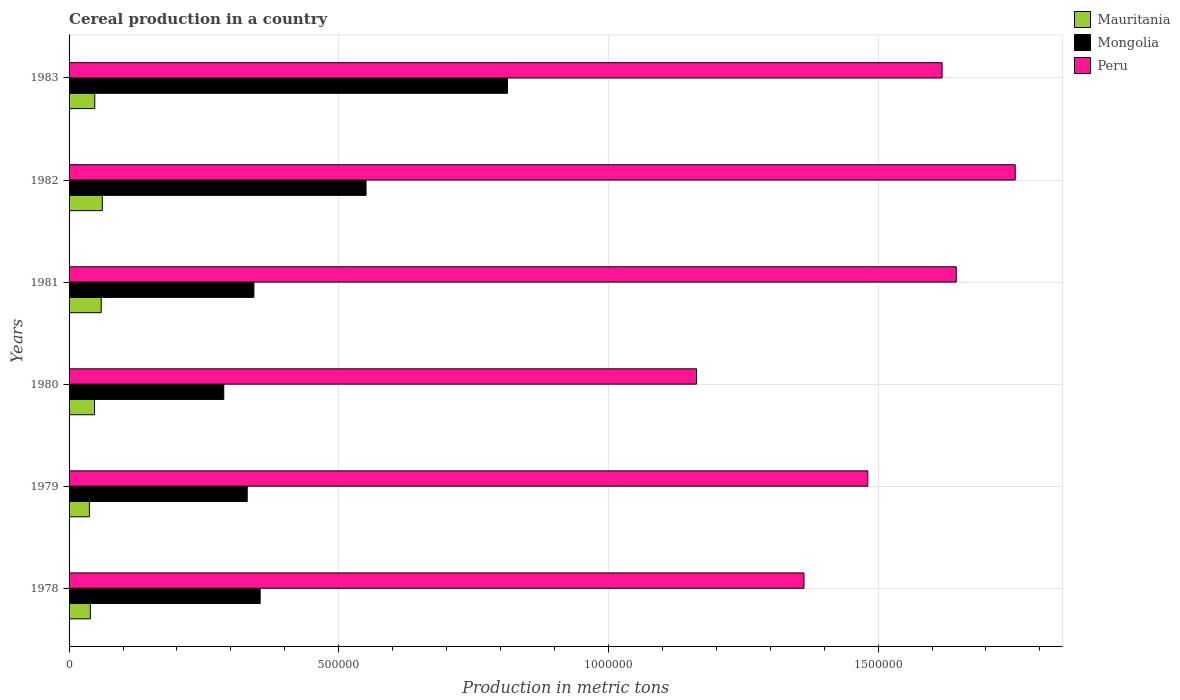Are the number of bars per tick equal to the number of legend labels?
Your response must be concise. Yes. Are the number of bars on each tick of the Y-axis equal?
Offer a very short reply. Yes. How many bars are there on the 3rd tick from the top?
Your answer should be very brief. 3. What is the label of the 6th group of bars from the top?
Offer a very short reply. 1978. In how many cases, is the number of bars for a given year not equal to the number of legend labels?
Offer a terse response. 0. What is the total cereal production in Mauritania in 1982?
Make the answer very short. 6.16e+04. Across all years, what is the maximum total cereal production in Mauritania?
Offer a terse response. 6.16e+04. Across all years, what is the minimum total cereal production in Mongolia?
Keep it short and to the point. 2.87e+05. In which year was the total cereal production in Peru maximum?
Give a very brief answer. 1982. In which year was the total cereal production in Peru minimum?
Make the answer very short. 1980. What is the total total cereal production in Mauritania in the graph?
Your response must be concise. 2.93e+05. What is the difference between the total cereal production in Mongolia in 1978 and that in 1980?
Give a very brief answer. 6.75e+04. What is the difference between the total cereal production in Mauritania in 1978 and the total cereal production in Peru in 1982?
Offer a very short reply. -1.71e+06. What is the average total cereal production in Mauritania per year?
Your answer should be very brief. 4.89e+04. In the year 1983, what is the difference between the total cereal production in Peru and total cereal production in Mauritania?
Give a very brief answer. 1.57e+06. What is the ratio of the total cereal production in Peru in 1980 to that in 1983?
Offer a terse response. 0.72. What is the difference between the highest and the second highest total cereal production in Mongolia?
Provide a succinct answer. 2.62e+05. What is the difference between the highest and the lowest total cereal production in Mongolia?
Offer a terse response. 5.26e+05. What does the 2nd bar from the top in 1979 represents?
Provide a short and direct response. Mongolia. What does the 1st bar from the bottom in 1983 represents?
Your answer should be very brief. Mauritania. Is it the case that in every year, the sum of the total cereal production in Peru and total cereal production in Mauritania is greater than the total cereal production in Mongolia?
Offer a terse response. Yes. Are all the bars in the graph horizontal?
Your answer should be very brief. Yes. How many years are there in the graph?
Ensure brevity in your answer.  6. What is the difference between two consecutive major ticks on the X-axis?
Your answer should be compact. 5.00e+05. How many legend labels are there?
Your answer should be compact. 3. What is the title of the graph?
Offer a very short reply. Cereal production in a country. What is the label or title of the X-axis?
Your answer should be very brief. Production in metric tons. What is the Production in metric tons in Mauritania in 1978?
Make the answer very short. 3.94e+04. What is the Production in metric tons of Mongolia in 1978?
Your answer should be compact. 3.54e+05. What is the Production in metric tons of Peru in 1978?
Make the answer very short. 1.36e+06. What is the Production in metric tons of Mauritania in 1979?
Provide a succinct answer. 3.77e+04. What is the Production in metric tons of Mongolia in 1979?
Your answer should be very brief. 3.30e+05. What is the Production in metric tons in Peru in 1979?
Offer a terse response. 1.48e+06. What is the Production in metric tons of Mauritania in 1980?
Your answer should be very brief. 4.72e+04. What is the Production in metric tons in Mongolia in 1980?
Your answer should be very brief. 2.87e+05. What is the Production in metric tons in Peru in 1980?
Your answer should be compact. 1.16e+06. What is the Production in metric tons of Mauritania in 1981?
Your answer should be very brief. 5.96e+04. What is the Production in metric tons of Mongolia in 1981?
Provide a short and direct response. 3.43e+05. What is the Production in metric tons in Peru in 1981?
Offer a terse response. 1.64e+06. What is the Production in metric tons of Mauritania in 1982?
Your answer should be compact. 6.16e+04. What is the Production in metric tons of Mongolia in 1982?
Provide a succinct answer. 5.51e+05. What is the Production in metric tons of Peru in 1982?
Your answer should be very brief. 1.75e+06. What is the Production in metric tons in Mauritania in 1983?
Provide a succinct answer. 4.76e+04. What is the Production in metric tons of Mongolia in 1983?
Your answer should be very brief. 8.13e+05. What is the Production in metric tons of Peru in 1983?
Your answer should be very brief. 1.62e+06. Across all years, what is the maximum Production in metric tons in Mauritania?
Offer a terse response. 6.16e+04. Across all years, what is the maximum Production in metric tons in Mongolia?
Make the answer very short. 8.13e+05. Across all years, what is the maximum Production in metric tons in Peru?
Make the answer very short. 1.75e+06. Across all years, what is the minimum Production in metric tons in Mauritania?
Offer a very short reply. 3.77e+04. Across all years, what is the minimum Production in metric tons of Mongolia?
Ensure brevity in your answer.  2.87e+05. Across all years, what is the minimum Production in metric tons of Peru?
Provide a short and direct response. 1.16e+06. What is the total Production in metric tons in Mauritania in the graph?
Your answer should be compact. 2.93e+05. What is the total Production in metric tons in Mongolia in the graph?
Your response must be concise. 2.68e+06. What is the total Production in metric tons in Peru in the graph?
Ensure brevity in your answer.  9.02e+06. What is the difference between the Production in metric tons in Mauritania in 1978 and that in 1979?
Ensure brevity in your answer.  1730. What is the difference between the Production in metric tons of Mongolia in 1978 and that in 1979?
Your answer should be very brief. 2.40e+04. What is the difference between the Production in metric tons in Peru in 1978 and that in 1979?
Your answer should be very brief. -1.18e+05. What is the difference between the Production in metric tons of Mauritania in 1978 and that in 1980?
Keep it short and to the point. -7800. What is the difference between the Production in metric tons of Mongolia in 1978 and that in 1980?
Offer a very short reply. 6.75e+04. What is the difference between the Production in metric tons of Peru in 1978 and that in 1980?
Your response must be concise. 1.99e+05. What is the difference between the Production in metric tons in Mauritania in 1978 and that in 1981?
Offer a terse response. -2.02e+04. What is the difference between the Production in metric tons of Mongolia in 1978 and that in 1981?
Ensure brevity in your answer.  1.16e+04. What is the difference between the Production in metric tons of Peru in 1978 and that in 1981?
Keep it short and to the point. -2.82e+05. What is the difference between the Production in metric tons of Mauritania in 1978 and that in 1982?
Give a very brief answer. -2.22e+04. What is the difference between the Production in metric tons of Mongolia in 1978 and that in 1982?
Give a very brief answer. -1.96e+05. What is the difference between the Production in metric tons in Peru in 1978 and that in 1982?
Make the answer very short. -3.92e+05. What is the difference between the Production in metric tons of Mauritania in 1978 and that in 1983?
Your response must be concise. -8210. What is the difference between the Production in metric tons of Mongolia in 1978 and that in 1983?
Keep it short and to the point. -4.58e+05. What is the difference between the Production in metric tons of Peru in 1978 and that in 1983?
Make the answer very short. -2.56e+05. What is the difference between the Production in metric tons in Mauritania in 1979 and that in 1980?
Your response must be concise. -9530. What is the difference between the Production in metric tons in Mongolia in 1979 and that in 1980?
Offer a terse response. 4.35e+04. What is the difference between the Production in metric tons of Peru in 1979 and that in 1980?
Your answer should be compact. 3.18e+05. What is the difference between the Production in metric tons in Mauritania in 1979 and that in 1981?
Provide a succinct answer. -2.19e+04. What is the difference between the Production in metric tons in Mongolia in 1979 and that in 1981?
Make the answer very short. -1.24e+04. What is the difference between the Production in metric tons of Peru in 1979 and that in 1981?
Provide a succinct answer. -1.64e+05. What is the difference between the Production in metric tons of Mauritania in 1979 and that in 1982?
Your answer should be very brief. -2.39e+04. What is the difference between the Production in metric tons of Mongolia in 1979 and that in 1982?
Keep it short and to the point. -2.20e+05. What is the difference between the Production in metric tons of Peru in 1979 and that in 1982?
Offer a very short reply. -2.73e+05. What is the difference between the Production in metric tons in Mauritania in 1979 and that in 1983?
Give a very brief answer. -9940. What is the difference between the Production in metric tons in Mongolia in 1979 and that in 1983?
Give a very brief answer. -4.82e+05. What is the difference between the Production in metric tons in Peru in 1979 and that in 1983?
Keep it short and to the point. -1.38e+05. What is the difference between the Production in metric tons in Mauritania in 1980 and that in 1981?
Keep it short and to the point. -1.24e+04. What is the difference between the Production in metric tons in Mongolia in 1980 and that in 1981?
Give a very brief answer. -5.59e+04. What is the difference between the Production in metric tons in Peru in 1980 and that in 1981?
Offer a very short reply. -4.82e+05. What is the difference between the Production in metric tons in Mauritania in 1980 and that in 1982?
Ensure brevity in your answer.  -1.44e+04. What is the difference between the Production in metric tons in Mongolia in 1980 and that in 1982?
Keep it short and to the point. -2.64e+05. What is the difference between the Production in metric tons in Peru in 1980 and that in 1982?
Your answer should be very brief. -5.91e+05. What is the difference between the Production in metric tons in Mauritania in 1980 and that in 1983?
Your answer should be very brief. -410. What is the difference between the Production in metric tons of Mongolia in 1980 and that in 1983?
Your response must be concise. -5.26e+05. What is the difference between the Production in metric tons in Peru in 1980 and that in 1983?
Your answer should be very brief. -4.55e+05. What is the difference between the Production in metric tons in Mauritania in 1981 and that in 1982?
Ensure brevity in your answer.  -2020. What is the difference between the Production in metric tons in Mongolia in 1981 and that in 1982?
Give a very brief answer. -2.08e+05. What is the difference between the Production in metric tons in Peru in 1981 and that in 1982?
Offer a terse response. -1.09e+05. What is the difference between the Production in metric tons of Mauritania in 1981 and that in 1983?
Your answer should be very brief. 1.20e+04. What is the difference between the Production in metric tons of Mongolia in 1981 and that in 1983?
Offer a very short reply. -4.70e+05. What is the difference between the Production in metric tons of Peru in 1981 and that in 1983?
Offer a terse response. 2.63e+04. What is the difference between the Production in metric tons in Mauritania in 1982 and that in 1983?
Offer a very short reply. 1.40e+04. What is the difference between the Production in metric tons in Mongolia in 1982 and that in 1983?
Your answer should be compact. -2.62e+05. What is the difference between the Production in metric tons of Peru in 1982 and that in 1983?
Make the answer very short. 1.36e+05. What is the difference between the Production in metric tons of Mauritania in 1978 and the Production in metric tons of Mongolia in 1979?
Your response must be concise. -2.91e+05. What is the difference between the Production in metric tons in Mauritania in 1978 and the Production in metric tons in Peru in 1979?
Your response must be concise. -1.44e+06. What is the difference between the Production in metric tons in Mongolia in 1978 and the Production in metric tons in Peru in 1979?
Make the answer very short. -1.13e+06. What is the difference between the Production in metric tons of Mauritania in 1978 and the Production in metric tons of Mongolia in 1980?
Offer a very short reply. -2.47e+05. What is the difference between the Production in metric tons of Mauritania in 1978 and the Production in metric tons of Peru in 1980?
Provide a short and direct response. -1.12e+06. What is the difference between the Production in metric tons of Mongolia in 1978 and the Production in metric tons of Peru in 1980?
Your response must be concise. -8.09e+05. What is the difference between the Production in metric tons of Mauritania in 1978 and the Production in metric tons of Mongolia in 1981?
Provide a succinct answer. -3.03e+05. What is the difference between the Production in metric tons of Mauritania in 1978 and the Production in metric tons of Peru in 1981?
Give a very brief answer. -1.61e+06. What is the difference between the Production in metric tons in Mongolia in 1978 and the Production in metric tons in Peru in 1981?
Give a very brief answer. -1.29e+06. What is the difference between the Production in metric tons of Mauritania in 1978 and the Production in metric tons of Mongolia in 1982?
Offer a very short reply. -5.11e+05. What is the difference between the Production in metric tons in Mauritania in 1978 and the Production in metric tons in Peru in 1982?
Offer a very short reply. -1.71e+06. What is the difference between the Production in metric tons of Mongolia in 1978 and the Production in metric tons of Peru in 1982?
Your answer should be very brief. -1.40e+06. What is the difference between the Production in metric tons in Mauritania in 1978 and the Production in metric tons in Mongolia in 1983?
Offer a very short reply. -7.73e+05. What is the difference between the Production in metric tons in Mauritania in 1978 and the Production in metric tons in Peru in 1983?
Make the answer very short. -1.58e+06. What is the difference between the Production in metric tons of Mongolia in 1978 and the Production in metric tons of Peru in 1983?
Make the answer very short. -1.26e+06. What is the difference between the Production in metric tons in Mauritania in 1979 and the Production in metric tons in Mongolia in 1980?
Give a very brief answer. -2.49e+05. What is the difference between the Production in metric tons of Mauritania in 1979 and the Production in metric tons of Peru in 1980?
Provide a short and direct response. -1.13e+06. What is the difference between the Production in metric tons in Mongolia in 1979 and the Production in metric tons in Peru in 1980?
Your response must be concise. -8.33e+05. What is the difference between the Production in metric tons in Mauritania in 1979 and the Production in metric tons in Mongolia in 1981?
Ensure brevity in your answer.  -3.05e+05. What is the difference between the Production in metric tons of Mauritania in 1979 and the Production in metric tons of Peru in 1981?
Give a very brief answer. -1.61e+06. What is the difference between the Production in metric tons in Mongolia in 1979 and the Production in metric tons in Peru in 1981?
Offer a very short reply. -1.31e+06. What is the difference between the Production in metric tons of Mauritania in 1979 and the Production in metric tons of Mongolia in 1982?
Your answer should be compact. -5.13e+05. What is the difference between the Production in metric tons of Mauritania in 1979 and the Production in metric tons of Peru in 1982?
Your answer should be very brief. -1.72e+06. What is the difference between the Production in metric tons of Mongolia in 1979 and the Production in metric tons of Peru in 1982?
Your answer should be compact. -1.42e+06. What is the difference between the Production in metric tons of Mauritania in 1979 and the Production in metric tons of Mongolia in 1983?
Give a very brief answer. -7.75e+05. What is the difference between the Production in metric tons in Mauritania in 1979 and the Production in metric tons in Peru in 1983?
Give a very brief answer. -1.58e+06. What is the difference between the Production in metric tons of Mongolia in 1979 and the Production in metric tons of Peru in 1983?
Make the answer very short. -1.29e+06. What is the difference between the Production in metric tons in Mauritania in 1980 and the Production in metric tons in Mongolia in 1981?
Offer a very short reply. -2.95e+05. What is the difference between the Production in metric tons in Mauritania in 1980 and the Production in metric tons in Peru in 1981?
Provide a succinct answer. -1.60e+06. What is the difference between the Production in metric tons of Mongolia in 1980 and the Production in metric tons of Peru in 1981?
Ensure brevity in your answer.  -1.36e+06. What is the difference between the Production in metric tons in Mauritania in 1980 and the Production in metric tons in Mongolia in 1982?
Give a very brief answer. -5.03e+05. What is the difference between the Production in metric tons in Mauritania in 1980 and the Production in metric tons in Peru in 1982?
Offer a very short reply. -1.71e+06. What is the difference between the Production in metric tons of Mongolia in 1980 and the Production in metric tons of Peru in 1982?
Make the answer very short. -1.47e+06. What is the difference between the Production in metric tons of Mauritania in 1980 and the Production in metric tons of Mongolia in 1983?
Offer a terse response. -7.66e+05. What is the difference between the Production in metric tons in Mauritania in 1980 and the Production in metric tons in Peru in 1983?
Give a very brief answer. -1.57e+06. What is the difference between the Production in metric tons in Mongolia in 1980 and the Production in metric tons in Peru in 1983?
Your answer should be compact. -1.33e+06. What is the difference between the Production in metric tons of Mauritania in 1981 and the Production in metric tons of Mongolia in 1982?
Your response must be concise. -4.91e+05. What is the difference between the Production in metric tons of Mauritania in 1981 and the Production in metric tons of Peru in 1982?
Ensure brevity in your answer.  -1.69e+06. What is the difference between the Production in metric tons in Mongolia in 1981 and the Production in metric tons in Peru in 1982?
Your answer should be very brief. -1.41e+06. What is the difference between the Production in metric tons in Mauritania in 1981 and the Production in metric tons in Mongolia in 1983?
Your answer should be compact. -7.53e+05. What is the difference between the Production in metric tons in Mauritania in 1981 and the Production in metric tons in Peru in 1983?
Provide a succinct answer. -1.56e+06. What is the difference between the Production in metric tons of Mongolia in 1981 and the Production in metric tons of Peru in 1983?
Provide a succinct answer. -1.28e+06. What is the difference between the Production in metric tons of Mauritania in 1982 and the Production in metric tons of Mongolia in 1983?
Your response must be concise. -7.51e+05. What is the difference between the Production in metric tons of Mauritania in 1982 and the Production in metric tons of Peru in 1983?
Provide a succinct answer. -1.56e+06. What is the difference between the Production in metric tons of Mongolia in 1982 and the Production in metric tons of Peru in 1983?
Keep it short and to the point. -1.07e+06. What is the average Production in metric tons in Mauritania per year?
Give a very brief answer. 4.89e+04. What is the average Production in metric tons in Mongolia per year?
Provide a short and direct response. 4.46e+05. What is the average Production in metric tons of Peru per year?
Make the answer very short. 1.50e+06. In the year 1978, what is the difference between the Production in metric tons of Mauritania and Production in metric tons of Mongolia?
Ensure brevity in your answer.  -3.15e+05. In the year 1978, what is the difference between the Production in metric tons of Mauritania and Production in metric tons of Peru?
Provide a short and direct response. -1.32e+06. In the year 1978, what is the difference between the Production in metric tons in Mongolia and Production in metric tons in Peru?
Make the answer very short. -1.01e+06. In the year 1979, what is the difference between the Production in metric tons of Mauritania and Production in metric tons of Mongolia?
Your response must be concise. -2.93e+05. In the year 1979, what is the difference between the Production in metric tons of Mauritania and Production in metric tons of Peru?
Provide a short and direct response. -1.44e+06. In the year 1979, what is the difference between the Production in metric tons of Mongolia and Production in metric tons of Peru?
Your answer should be very brief. -1.15e+06. In the year 1980, what is the difference between the Production in metric tons in Mauritania and Production in metric tons in Mongolia?
Offer a very short reply. -2.40e+05. In the year 1980, what is the difference between the Production in metric tons of Mauritania and Production in metric tons of Peru?
Provide a succinct answer. -1.12e+06. In the year 1980, what is the difference between the Production in metric tons of Mongolia and Production in metric tons of Peru?
Your answer should be compact. -8.77e+05. In the year 1981, what is the difference between the Production in metric tons of Mauritania and Production in metric tons of Mongolia?
Your answer should be very brief. -2.83e+05. In the year 1981, what is the difference between the Production in metric tons in Mauritania and Production in metric tons in Peru?
Keep it short and to the point. -1.59e+06. In the year 1981, what is the difference between the Production in metric tons in Mongolia and Production in metric tons in Peru?
Make the answer very short. -1.30e+06. In the year 1982, what is the difference between the Production in metric tons in Mauritania and Production in metric tons in Mongolia?
Provide a short and direct response. -4.89e+05. In the year 1982, what is the difference between the Production in metric tons of Mauritania and Production in metric tons of Peru?
Your answer should be very brief. -1.69e+06. In the year 1982, what is the difference between the Production in metric tons in Mongolia and Production in metric tons in Peru?
Your response must be concise. -1.20e+06. In the year 1983, what is the difference between the Production in metric tons of Mauritania and Production in metric tons of Mongolia?
Offer a very short reply. -7.65e+05. In the year 1983, what is the difference between the Production in metric tons in Mauritania and Production in metric tons in Peru?
Offer a terse response. -1.57e+06. In the year 1983, what is the difference between the Production in metric tons of Mongolia and Production in metric tons of Peru?
Keep it short and to the point. -8.06e+05. What is the ratio of the Production in metric tons in Mauritania in 1978 to that in 1979?
Provide a short and direct response. 1.05. What is the ratio of the Production in metric tons in Mongolia in 1978 to that in 1979?
Provide a succinct answer. 1.07. What is the ratio of the Production in metric tons of Peru in 1978 to that in 1979?
Give a very brief answer. 0.92. What is the ratio of the Production in metric tons of Mauritania in 1978 to that in 1980?
Provide a short and direct response. 0.83. What is the ratio of the Production in metric tons of Mongolia in 1978 to that in 1980?
Ensure brevity in your answer.  1.24. What is the ratio of the Production in metric tons of Peru in 1978 to that in 1980?
Ensure brevity in your answer.  1.17. What is the ratio of the Production in metric tons in Mauritania in 1978 to that in 1981?
Offer a terse response. 0.66. What is the ratio of the Production in metric tons in Mongolia in 1978 to that in 1981?
Give a very brief answer. 1.03. What is the ratio of the Production in metric tons of Peru in 1978 to that in 1981?
Make the answer very short. 0.83. What is the ratio of the Production in metric tons of Mauritania in 1978 to that in 1982?
Offer a terse response. 0.64. What is the ratio of the Production in metric tons in Mongolia in 1978 to that in 1982?
Give a very brief answer. 0.64. What is the ratio of the Production in metric tons of Peru in 1978 to that in 1982?
Offer a terse response. 0.78. What is the ratio of the Production in metric tons in Mauritania in 1978 to that in 1983?
Your answer should be compact. 0.83. What is the ratio of the Production in metric tons of Mongolia in 1978 to that in 1983?
Provide a short and direct response. 0.44. What is the ratio of the Production in metric tons in Peru in 1978 to that in 1983?
Give a very brief answer. 0.84. What is the ratio of the Production in metric tons of Mauritania in 1979 to that in 1980?
Keep it short and to the point. 0.8. What is the ratio of the Production in metric tons in Mongolia in 1979 to that in 1980?
Provide a short and direct response. 1.15. What is the ratio of the Production in metric tons of Peru in 1979 to that in 1980?
Your answer should be very brief. 1.27. What is the ratio of the Production in metric tons of Mauritania in 1979 to that in 1981?
Your answer should be very brief. 0.63. What is the ratio of the Production in metric tons of Mongolia in 1979 to that in 1981?
Your answer should be very brief. 0.96. What is the ratio of the Production in metric tons in Peru in 1979 to that in 1981?
Offer a very short reply. 0.9. What is the ratio of the Production in metric tons in Mauritania in 1979 to that in 1982?
Provide a short and direct response. 0.61. What is the ratio of the Production in metric tons in Mongolia in 1979 to that in 1982?
Your response must be concise. 0.6. What is the ratio of the Production in metric tons of Peru in 1979 to that in 1982?
Provide a succinct answer. 0.84. What is the ratio of the Production in metric tons in Mauritania in 1979 to that in 1983?
Your answer should be very brief. 0.79. What is the ratio of the Production in metric tons of Mongolia in 1979 to that in 1983?
Give a very brief answer. 0.41. What is the ratio of the Production in metric tons of Peru in 1979 to that in 1983?
Your response must be concise. 0.91. What is the ratio of the Production in metric tons in Mauritania in 1980 to that in 1981?
Make the answer very short. 0.79. What is the ratio of the Production in metric tons of Mongolia in 1980 to that in 1981?
Your answer should be compact. 0.84. What is the ratio of the Production in metric tons in Peru in 1980 to that in 1981?
Provide a succinct answer. 0.71. What is the ratio of the Production in metric tons of Mauritania in 1980 to that in 1982?
Keep it short and to the point. 0.77. What is the ratio of the Production in metric tons of Mongolia in 1980 to that in 1982?
Make the answer very short. 0.52. What is the ratio of the Production in metric tons of Peru in 1980 to that in 1982?
Keep it short and to the point. 0.66. What is the ratio of the Production in metric tons in Mongolia in 1980 to that in 1983?
Give a very brief answer. 0.35. What is the ratio of the Production in metric tons of Peru in 1980 to that in 1983?
Your response must be concise. 0.72. What is the ratio of the Production in metric tons of Mauritania in 1981 to that in 1982?
Keep it short and to the point. 0.97. What is the ratio of the Production in metric tons in Mongolia in 1981 to that in 1982?
Keep it short and to the point. 0.62. What is the ratio of the Production in metric tons of Peru in 1981 to that in 1982?
Provide a short and direct response. 0.94. What is the ratio of the Production in metric tons of Mauritania in 1981 to that in 1983?
Provide a succinct answer. 1.25. What is the ratio of the Production in metric tons of Mongolia in 1981 to that in 1983?
Your answer should be very brief. 0.42. What is the ratio of the Production in metric tons in Peru in 1981 to that in 1983?
Your answer should be very brief. 1.02. What is the ratio of the Production in metric tons in Mauritania in 1982 to that in 1983?
Your answer should be very brief. 1.29. What is the ratio of the Production in metric tons of Mongolia in 1982 to that in 1983?
Your answer should be compact. 0.68. What is the ratio of the Production in metric tons in Peru in 1982 to that in 1983?
Ensure brevity in your answer.  1.08. What is the difference between the highest and the second highest Production in metric tons of Mauritania?
Keep it short and to the point. 2020. What is the difference between the highest and the second highest Production in metric tons in Mongolia?
Your response must be concise. 2.62e+05. What is the difference between the highest and the second highest Production in metric tons in Peru?
Offer a very short reply. 1.09e+05. What is the difference between the highest and the lowest Production in metric tons in Mauritania?
Make the answer very short. 2.39e+04. What is the difference between the highest and the lowest Production in metric tons in Mongolia?
Give a very brief answer. 5.26e+05. What is the difference between the highest and the lowest Production in metric tons of Peru?
Offer a very short reply. 5.91e+05. 